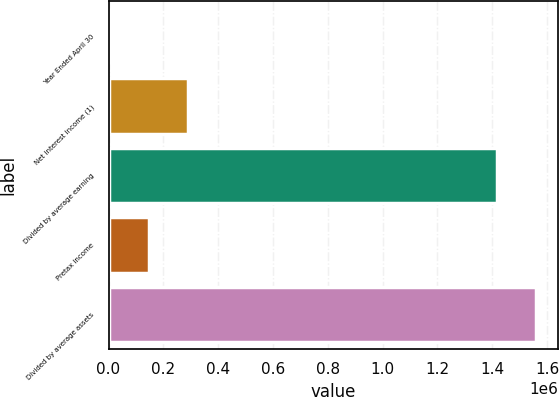<chart> <loc_0><loc_0><loc_500><loc_500><bar_chart><fcel>Year Ended April 30<fcel>Net interest income (1)<fcel>Divided by average earning<fcel>Pretax income<fcel>Divided by average assets<nl><fcel>2008<fcel>290180<fcel>1.41737e+06<fcel>146094<fcel>1.56145e+06<nl></chart> 